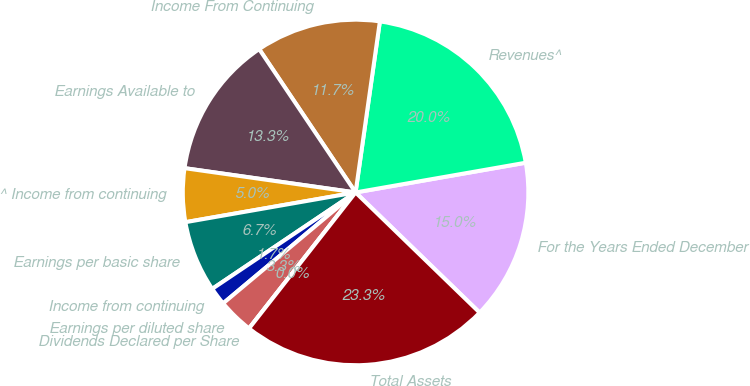Convert chart to OTSL. <chart><loc_0><loc_0><loc_500><loc_500><pie_chart><fcel>For the Years Ended December<fcel>Revenues^<fcel>Income From Continuing<fcel>Earnings Available to<fcel>^ Income from continuing<fcel>Earnings per basic share<fcel>Income from continuing<fcel>Earnings per diluted share<fcel>Dividends Declared per Share<fcel>Total Assets<nl><fcel>15.0%<fcel>20.0%<fcel>11.67%<fcel>13.33%<fcel>5.0%<fcel>6.67%<fcel>1.67%<fcel>3.33%<fcel>0.0%<fcel>23.33%<nl></chart> 